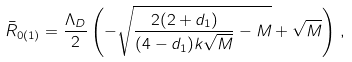Convert formula to latex. <formula><loc_0><loc_0><loc_500><loc_500>\bar { R } _ { 0 ( 1 ) } = \frac { \Lambda _ { D } } { 2 } \left ( - \sqrt { \frac { 2 ( 2 + d _ { 1 } ) } { ( 4 - d _ { 1 } ) k \sqrt { M } } - M } + \sqrt { M } \right ) \, ,</formula> 